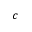Convert formula to latex. <formula><loc_0><loc_0><loc_500><loc_500>c</formula> 